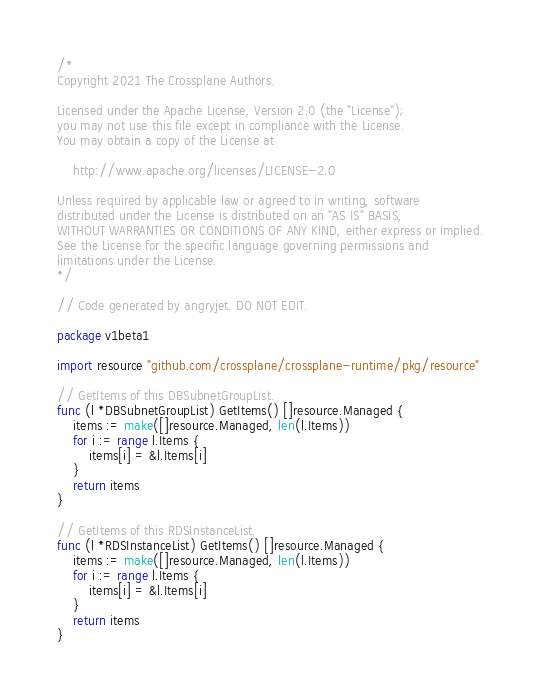Convert code to text. <code><loc_0><loc_0><loc_500><loc_500><_Go_>/*
Copyright 2021 The Crossplane Authors.

Licensed under the Apache License, Version 2.0 (the "License");
you may not use this file except in compliance with the License.
You may obtain a copy of the License at

    http://www.apache.org/licenses/LICENSE-2.0

Unless required by applicable law or agreed to in writing, software
distributed under the License is distributed on an "AS IS" BASIS,
WITHOUT WARRANTIES OR CONDITIONS OF ANY KIND, either express or implied.
See the License for the specific language governing permissions and
limitations under the License.
*/

// Code generated by angryjet. DO NOT EDIT.

package v1beta1

import resource "github.com/crossplane/crossplane-runtime/pkg/resource"

// GetItems of this DBSubnetGroupList.
func (l *DBSubnetGroupList) GetItems() []resource.Managed {
	items := make([]resource.Managed, len(l.Items))
	for i := range l.Items {
		items[i] = &l.Items[i]
	}
	return items
}

// GetItems of this RDSInstanceList.
func (l *RDSInstanceList) GetItems() []resource.Managed {
	items := make([]resource.Managed, len(l.Items))
	for i := range l.Items {
		items[i] = &l.Items[i]
	}
	return items
}
</code> 